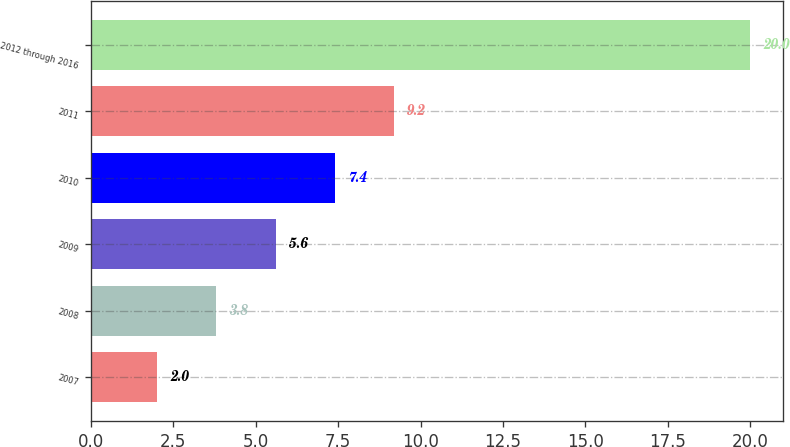Convert chart. <chart><loc_0><loc_0><loc_500><loc_500><bar_chart><fcel>2007<fcel>2008<fcel>2009<fcel>2010<fcel>2011<fcel>2012 through 2016<nl><fcel>2<fcel>3.8<fcel>5.6<fcel>7.4<fcel>9.2<fcel>20<nl></chart> 